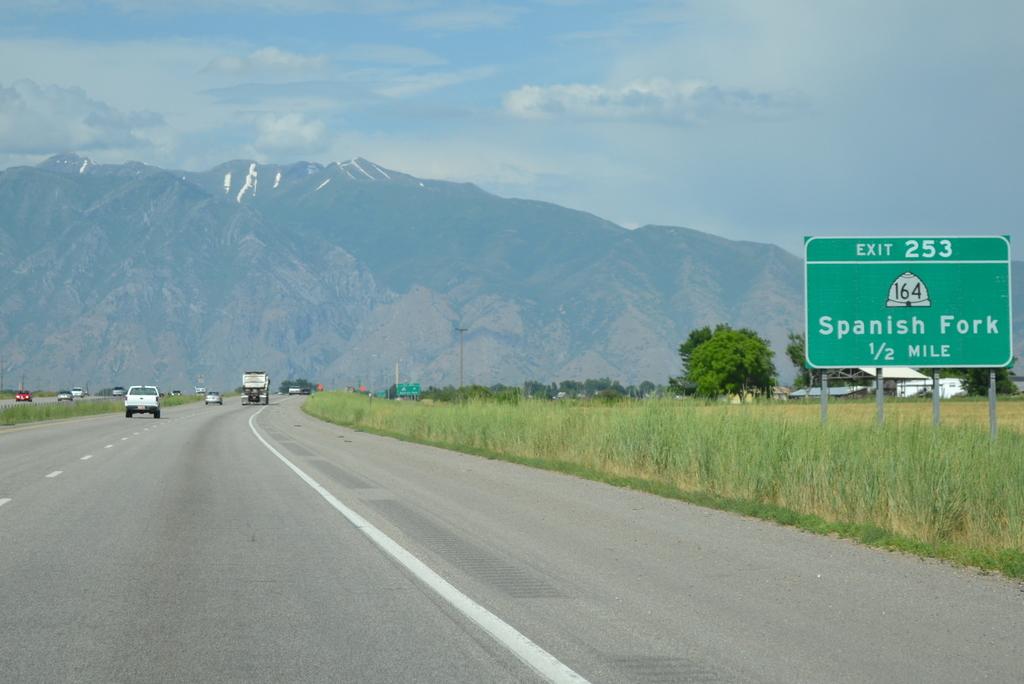How far is the nearest exit?
Offer a terse response. 1/2 mile. What exist is next?
Offer a very short reply. 253. 